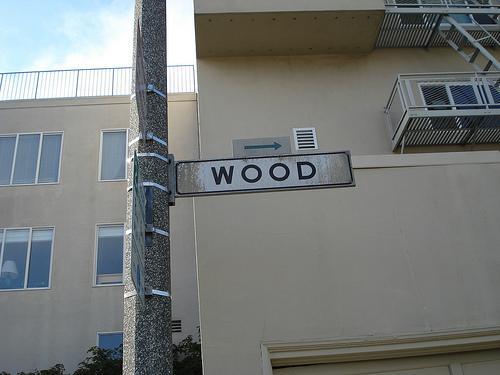Provide a comprehensive description of the signboard in the image. The signboard is black and white with the word "wood" written in black. It has an arrow pointing to the right and is fixed on a pole with three signposts. Describe the building in the picture. The building is beige and tan, with a smooth surface and white window frames. Can you describe some of the objects that interact with the building in the image? There are rungs on a pole, a metal ladder, and railing on the building's roof. What color is the sign in the image and what language is it in? The sign is black and white and is in English. How many windows are visible in the picture and what are their characteristics? There are four visible clear glass windows, differing in sizes and positions. How many sign posts are displayed on the pole in the image? There are three sign posts on the pole. What is the condition of the sky and clouds in the image? The sky is blue with large, white clouds. What is the sentiment conveyed by the image? The image conveys a peaceful and calm sentiment due to the blue sky, white clouds, and the presence of a sign with the word "wood." Discuss the main elements in the image that support complex reasoning tasks. The diverse objects in the image, such as the sign, building, pole, ladder, and railing, interact with each other and can be used to deduce information such as the building's purpose or location. What is the main characteristic of the plants near the wall? The main characteristic of the plants near the wall is that their leaves are green. Is there a red door frame in the image? No, it's not mentioned in the image. 